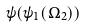<formula> <loc_0><loc_0><loc_500><loc_500>\psi ( \psi _ { 1 } ( \Omega _ { 2 } ) )</formula> 